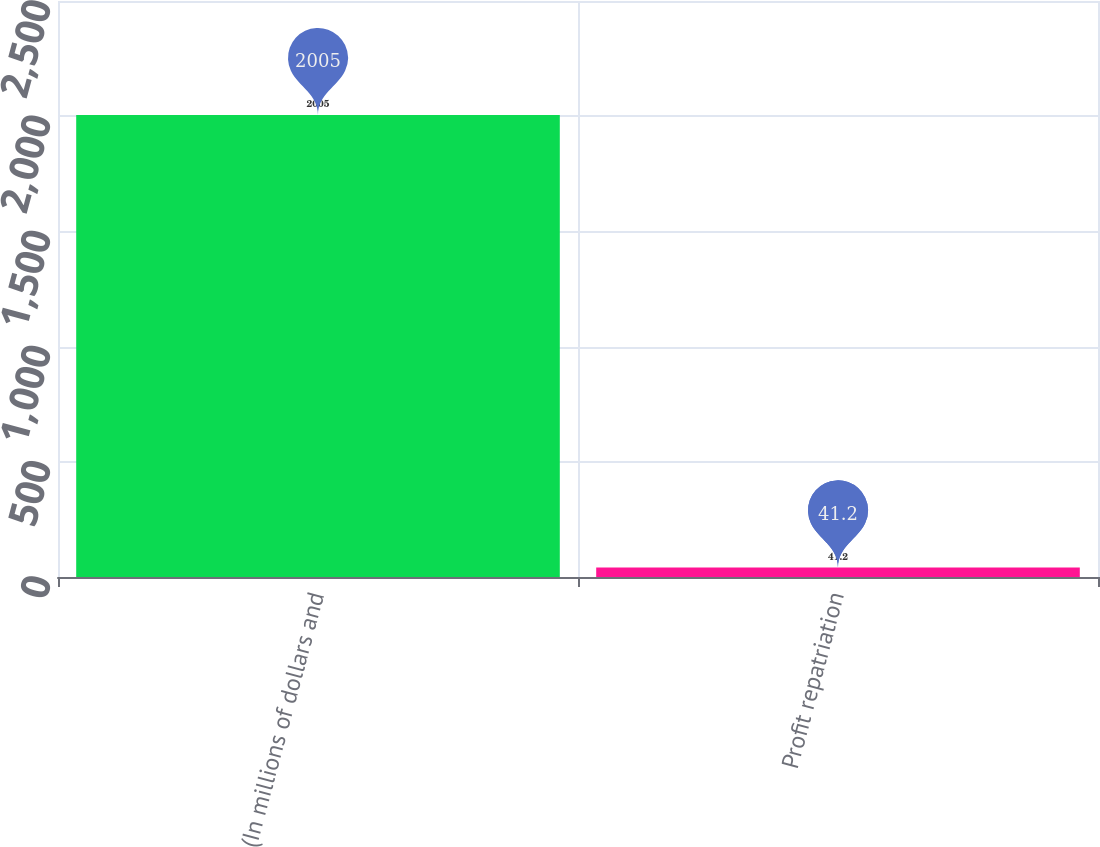Convert chart to OTSL. <chart><loc_0><loc_0><loc_500><loc_500><bar_chart><fcel>(In millions of dollars and<fcel>Profit repatriation<nl><fcel>2005<fcel>41.2<nl></chart> 